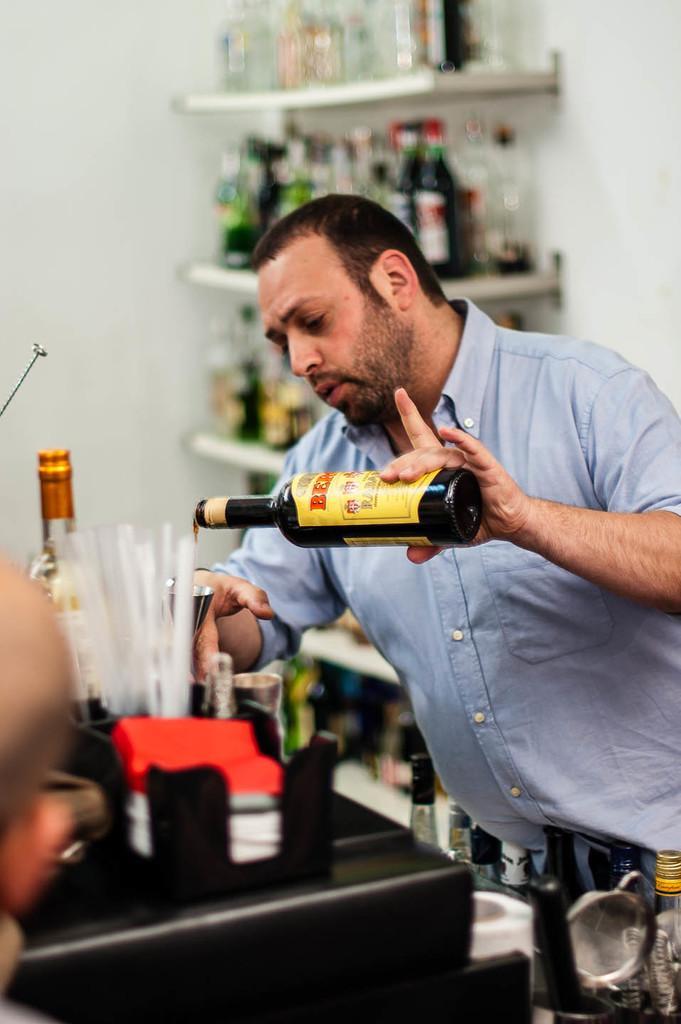Please provide a concise description of this image. A person is holding a bottle is having a logo. And there is a table. On the table there are bottles and many other items. In the background there are some racks. Inside the racks there are bottles. 